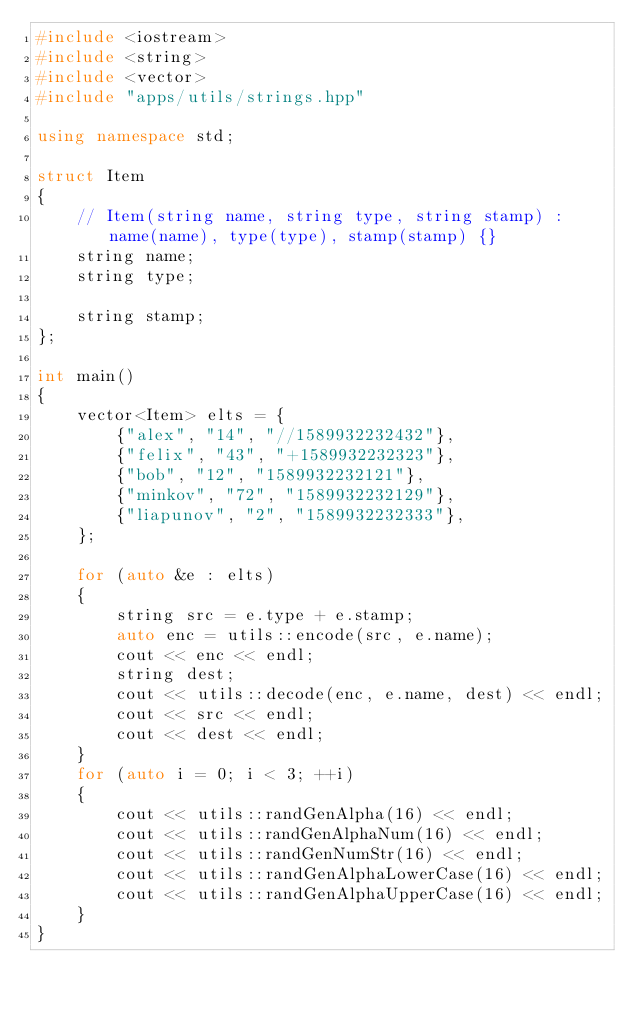Convert code to text. <code><loc_0><loc_0><loc_500><loc_500><_C++_>#include <iostream>
#include <string>
#include <vector>
#include "apps/utils/strings.hpp"

using namespace std;

struct Item
{
    // Item(string name, string type, string stamp) : name(name), type(type), stamp(stamp) {}
    string name;
    string type;

    string stamp;
};

int main()
{
    vector<Item> elts = {
        {"alex", "14", "//1589932232432"},
        {"felix", "43", "+1589932232323"},
        {"bob", "12", "1589932232121"},
        {"minkov", "72", "1589932232129"},
        {"liapunov", "2", "1589932232333"},
    };

    for (auto &e : elts)
    {
        string src = e.type + e.stamp;
        auto enc = utils::encode(src, e.name);
        cout << enc << endl;
        string dest;
        cout << utils::decode(enc, e.name, dest) << endl;
        cout << src << endl;
        cout << dest << endl;
    }
    for (auto i = 0; i < 3; ++i)
    {
        cout << utils::randGenAlpha(16) << endl;
        cout << utils::randGenAlphaNum(16) << endl;
        cout << utils::randGenNumStr(16) << endl;
        cout << utils::randGenAlphaLowerCase(16) << endl;
        cout << utils::randGenAlphaUpperCase(16) << endl;
    }
}
</code> 